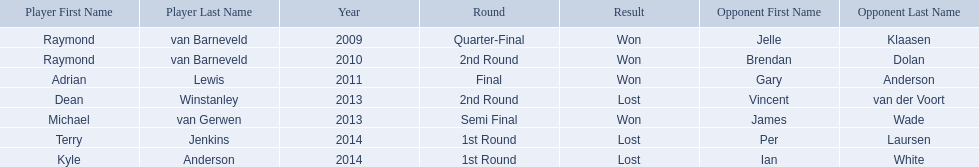What was the names of all the players? Raymond van Barneveld, Raymond van Barneveld, Adrian Lewis, Dean Winstanley, Michael van Gerwen, Terry Jenkins, Kyle Anderson. What years were the championship offered? 2009, 2010, 2011, 2013, 2013, 2014, 2014. Of these, who played in 2011? Adrian Lewis. 